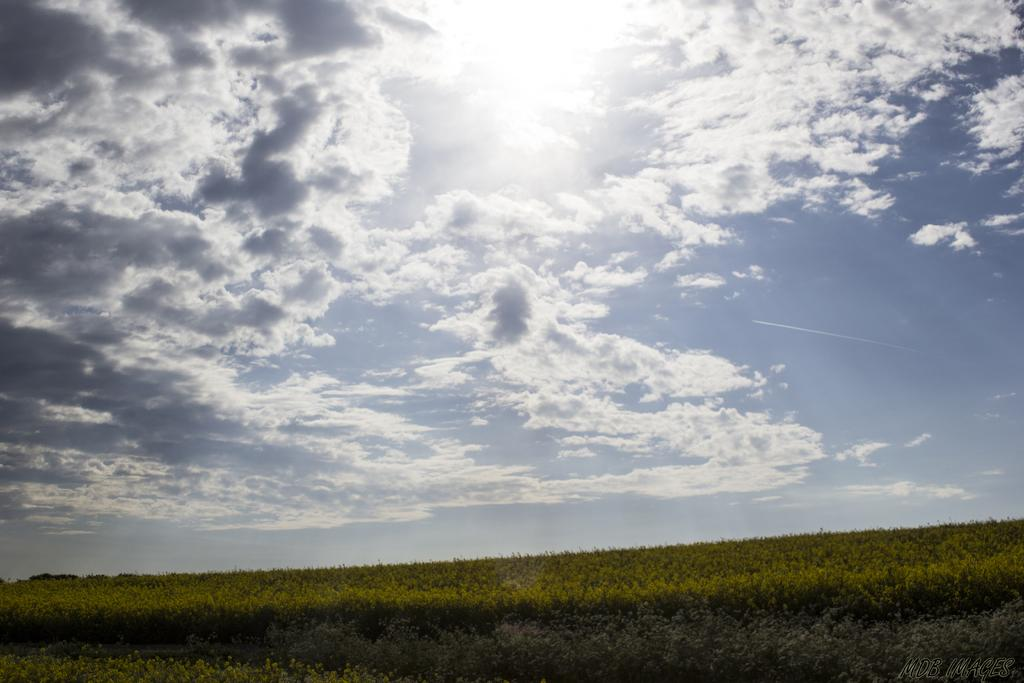What is located in the foreground of the image? There are plants in the foreground of the image. What celestial body is visible at the top of the image? The sun is visible at the top of the image. What else can be seen at the top of the image? The sky is visible at the top of the image. What type of cabbage is being used as a love letter in the image? There is no cabbage or love letter present in the image. 